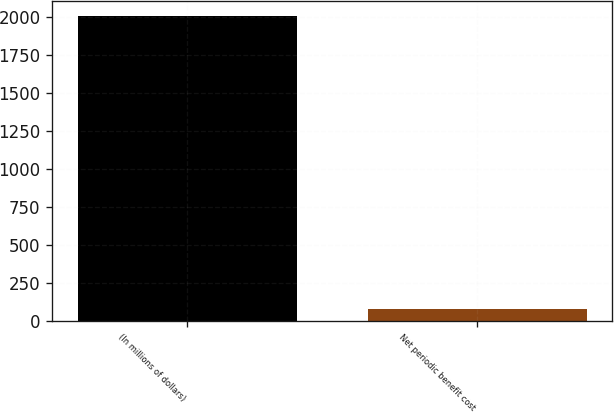Convert chart to OTSL. <chart><loc_0><loc_0><loc_500><loc_500><bar_chart><fcel>(In millions of dollars)<fcel>Net periodic benefit cost<nl><fcel>2011<fcel>83<nl></chart> 